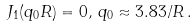Convert formula to latex. <formula><loc_0><loc_0><loc_500><loc_500>J _ { 1 } ( q _ { 0 } R ) = 0 , \, q _ { 0 } \approx 3 . 8 3 / R \, .</formula> 